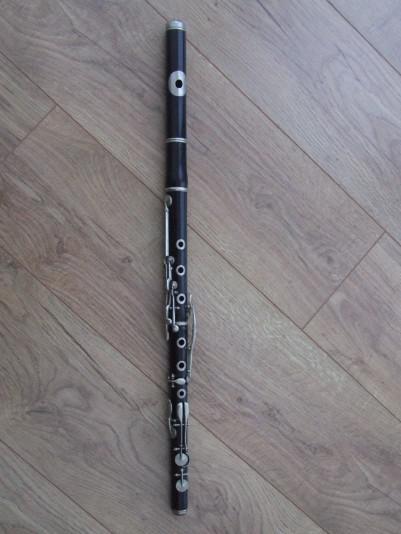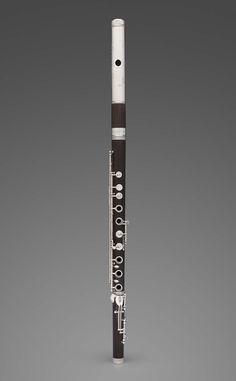The first image is the image on the left, the second image is the image on the right. Evaluate the accuracy of this statement regarding the images: "The instrument on the left is horizontal, the one on the right is diagonal.". Is it true? Answer yes or no. No. The first image is the image on the left, the second image is the image on the right. Examine the images to the left and right. Is the description "A flute is oriented vertically." accurate? Answer yes or no. Yes. 